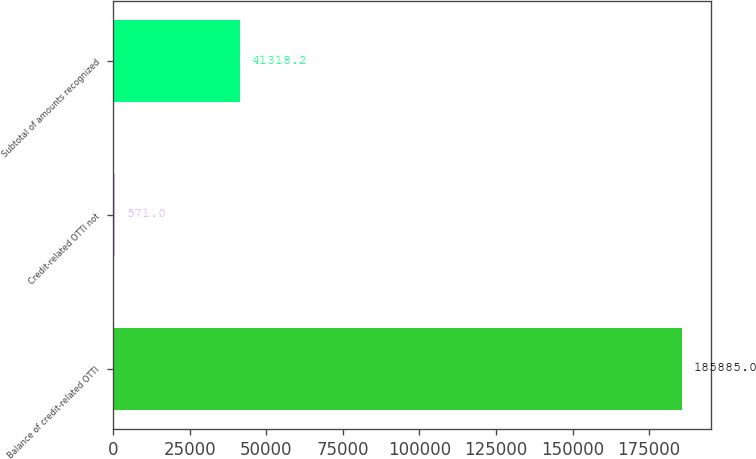<chart> <loc_0><loc_0><loc_500><loc_500><bar_chart><fcel>Balance of credit-related OTTI<fcel>Credit-related OTTI not<fcel>Subtotal of amounts recognized<nl><fcel>185885<fcel>571<fcel>41318.2<nl></chart> 